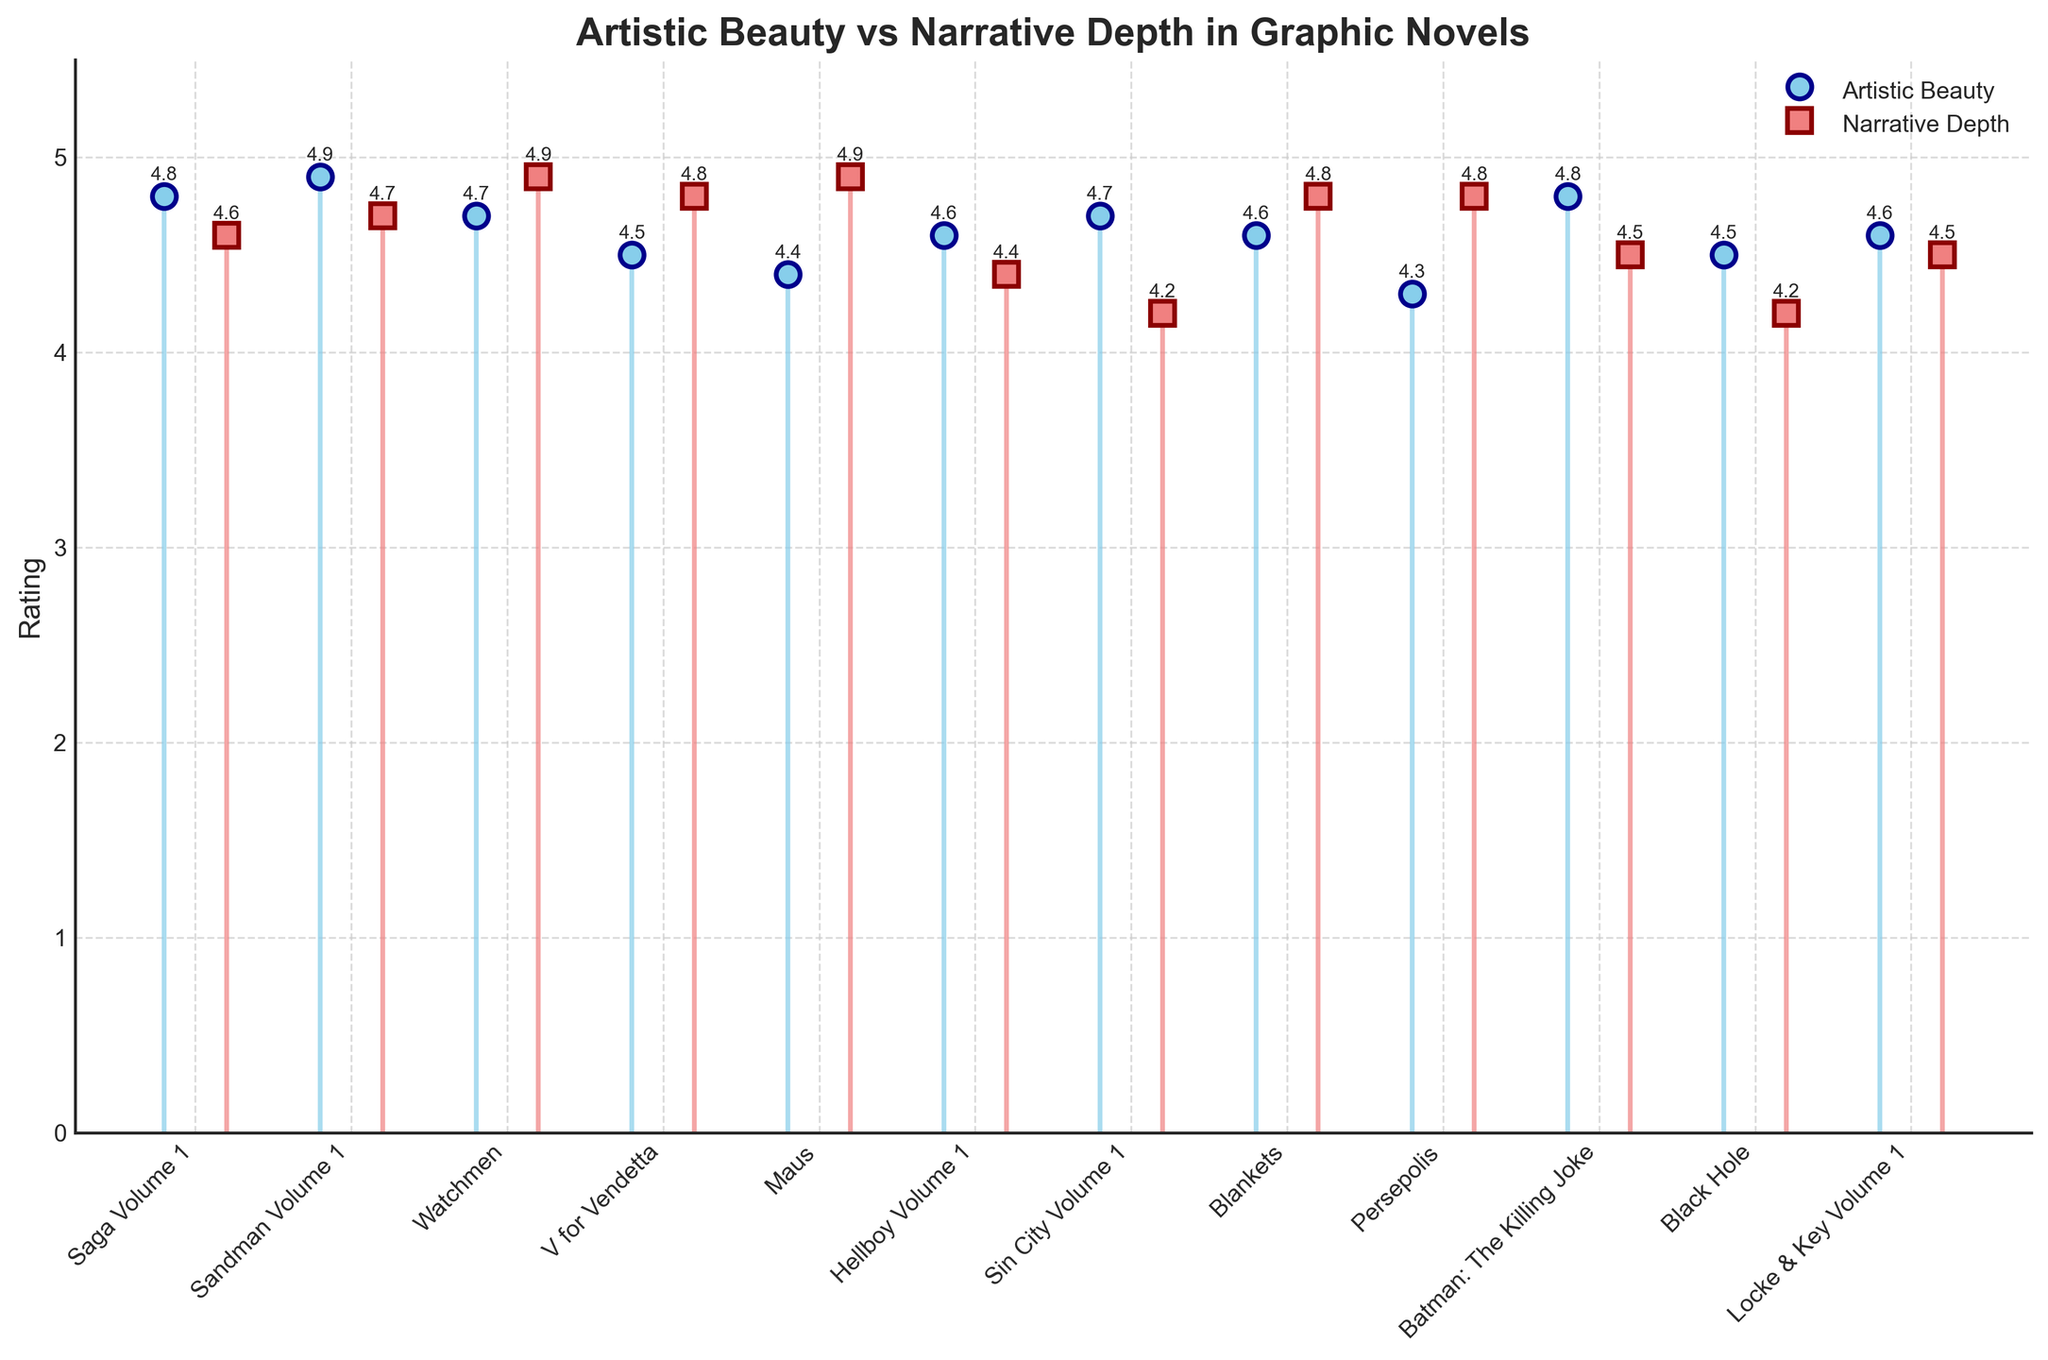How many graphic novels are rated in the figure? Count the number of titles on the x-axis. There are 12 titles.
Answer: 12 Which novel has the highest rating for artistic beauty? Look at the heights of the blue markers which represent artistic beauty. The highest rating is for "Sandman Volume 1" at 4.9.
Answer: Sandman Volume 1 Which novel has the lowest rating for narrative depth? Look at the heights of the red markers which represent narrative depth. The lowest rating is for "Sin City Volume 1" at 4.2.
Answer: Sin City Volume 1 What is the title of the plot? Read the text at the top center of the plot. The title is "Artistic Beauty vs Narrative Depth in Graphic Novels."
Answer: Artistic Beauty vs Narrative Depth in Graphic Novels How many novels have a narrative depth rating greater than 4.7? Check all red markers with heights above 4.7. There are 5 titles: "Sandman Volume 1," "Watchmen," "V for Vendetta," "Blankets," and "Persepolis."
Answer: 5 Which novels have the same rating for both artistic beauty and narrative depth? Compare the heights of blue and red markers for each novel. "Watchmen" (4.9, 4.9) and "Blankets" (4.6, 4.8) have the same ratings for artistic beauty and narrative depth.
Answer: Watchmen What is the difference between the highest and lowest artistic beauty ratings? The highest artistic beauty rating is 4.9 and the lowest is 4.3. The difference is 4.9 - 4.3 = 0.6.
Answer: 0.6 Which novel has the identical ratings for both artistic beauty and narrative depth the closest? Compare the ratings of both categories for each novel. The novel with almost identical ratings is “Watchmen” with 4.7 for artistic beauty and 4.9 for narrative depth.
Answer: Watchmen Which novels have an artistic beauty rating of exactly 4.6? Look at all blue markers with a rating of 4.6. The novels with this rating are "Hellboy Volume 1," "Blankets," and "Locke & Key Volume 1."
Answer: Hellboy Volume 1, Blankets, Locke & Key Volume 1 Which novel has the largest difference between its artistic beauty rating and narrative depth rating? Calculate the absolute difference for each novel’s ratings. "Sin City Volume 1" has 4.7 for artistic beauty and 4.2 for narrative depth. The difference is 0.5 which is the largest.
Answer: Sin City Volume 1 